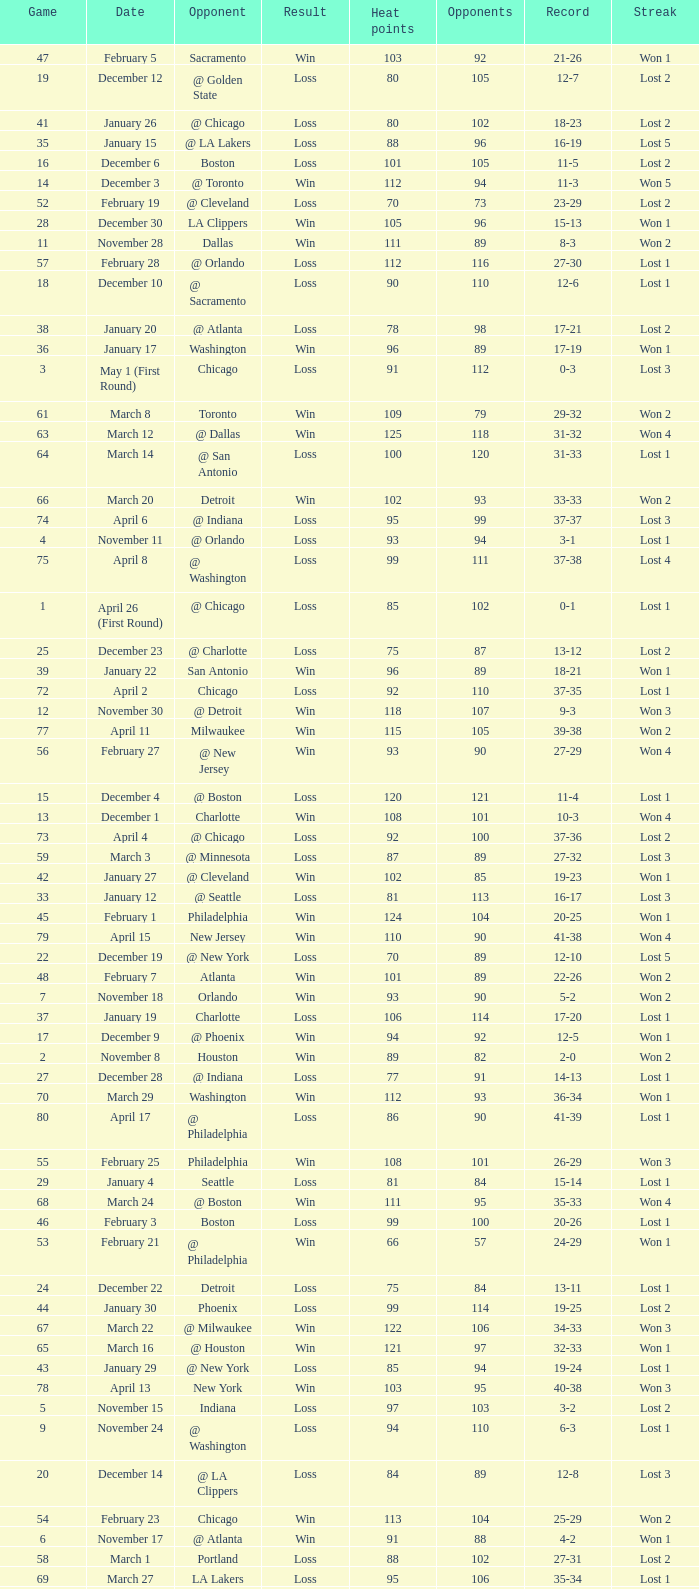What is the highest Game, when Opponents is less than 80, and when Record is "1-0"? 1.0. 